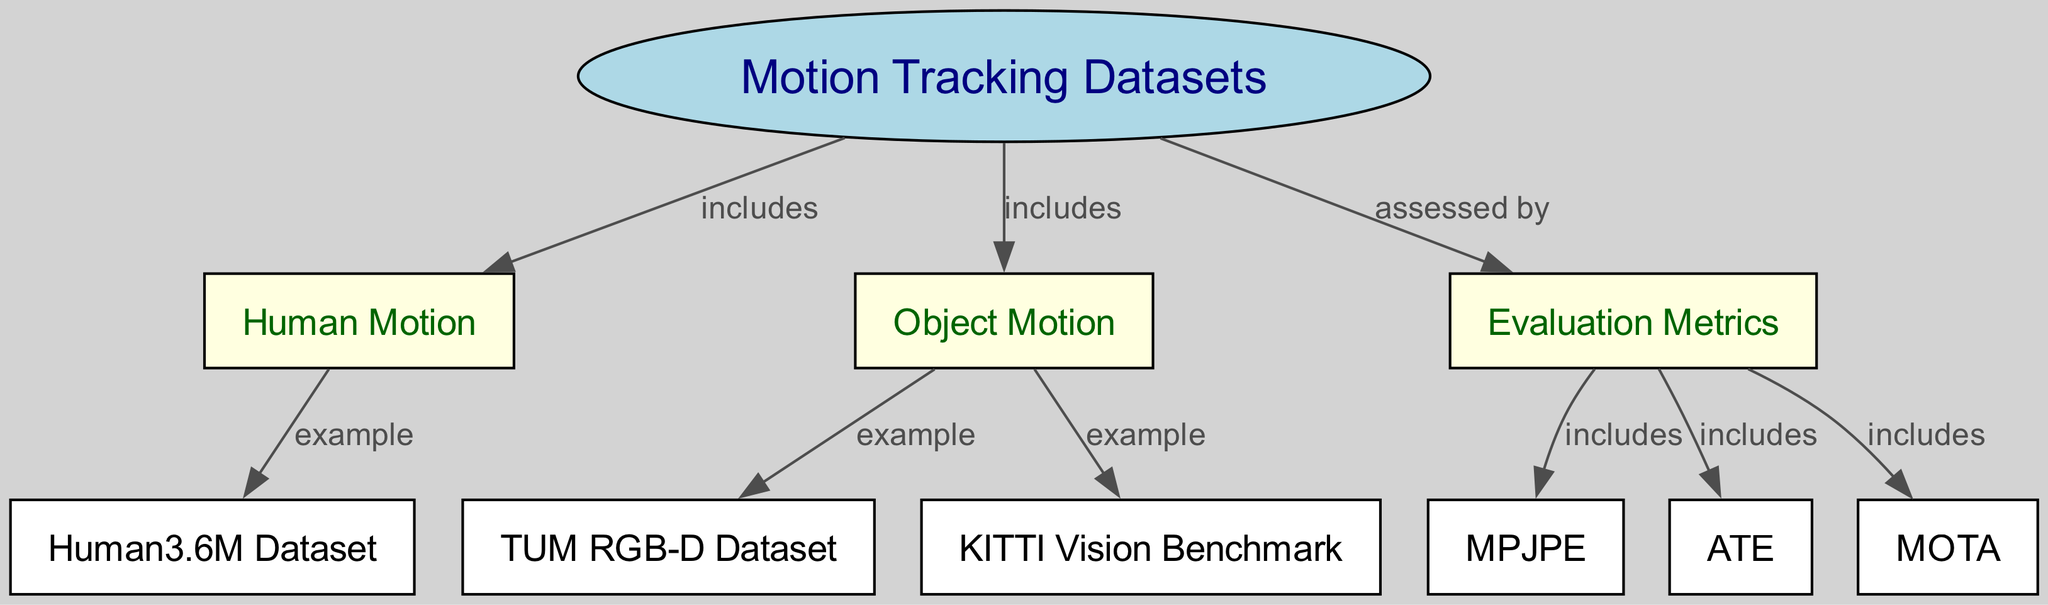What are the two main categories under motion tracking datasets? The diagram shows two categories under "Motion Tracking Datasets": "Human Motion" and "Object Motion."
Answer: Human Motion, Object Motion How many examples of human motion datasets are listed? The diagram provides one example of a human motion dataset, which is "Human3.6M Dataset."
Answer: One What evaluation metrics are included in the diagram? The diagram specifies three evaluation metrics connected to "Evaluation Metrics": "MPJPE," "ATE," and "MOTA."
Answer: MPJPE, ATE, MOTA Which dataset is an example of object motion? According to the diagram, "TUM RGB-D Dataset" and "KITTI Vision Benchmark" are listed as examples of object motion datasets.
Answer: TUM RGB-D Dataset, KITTI Vision Benchmark How many edges are connected to the "Evaluation Metrics" node? There are three edges leading from "Evaluation Metrics" to its included metrics: "MPJPE," "ATE," and "MOTA," indicating three connections.
Answer: Three Which dataset is specifically categorized under human motion? The diagram directly connects the "Human3.6M Dataset" to "Human Motion," identifying it as the specific dataset for that category.
Answer: Human3.6M Dataset What is the relationship between "Motion Tracking Datasets" and "Evaluation Metrics"? The relationship is described as "assessed by," indicating that the effectiveness of motion tracking datasets is evaluated using the listed metrics.
Answer: Assessed by What does ATE stand for in the context of the diagram? ATE is defined within the evaluation metrics, representing a specific metric used for measuring performance in motion tracking.
Answer: ATE What type of motion does the "KITTI Vision Benchmark" dataset represent? The "KITTI Vision Benchmark" is categorized under "Object Motion," as indicated in the diagram.
Answer: Object Motion 